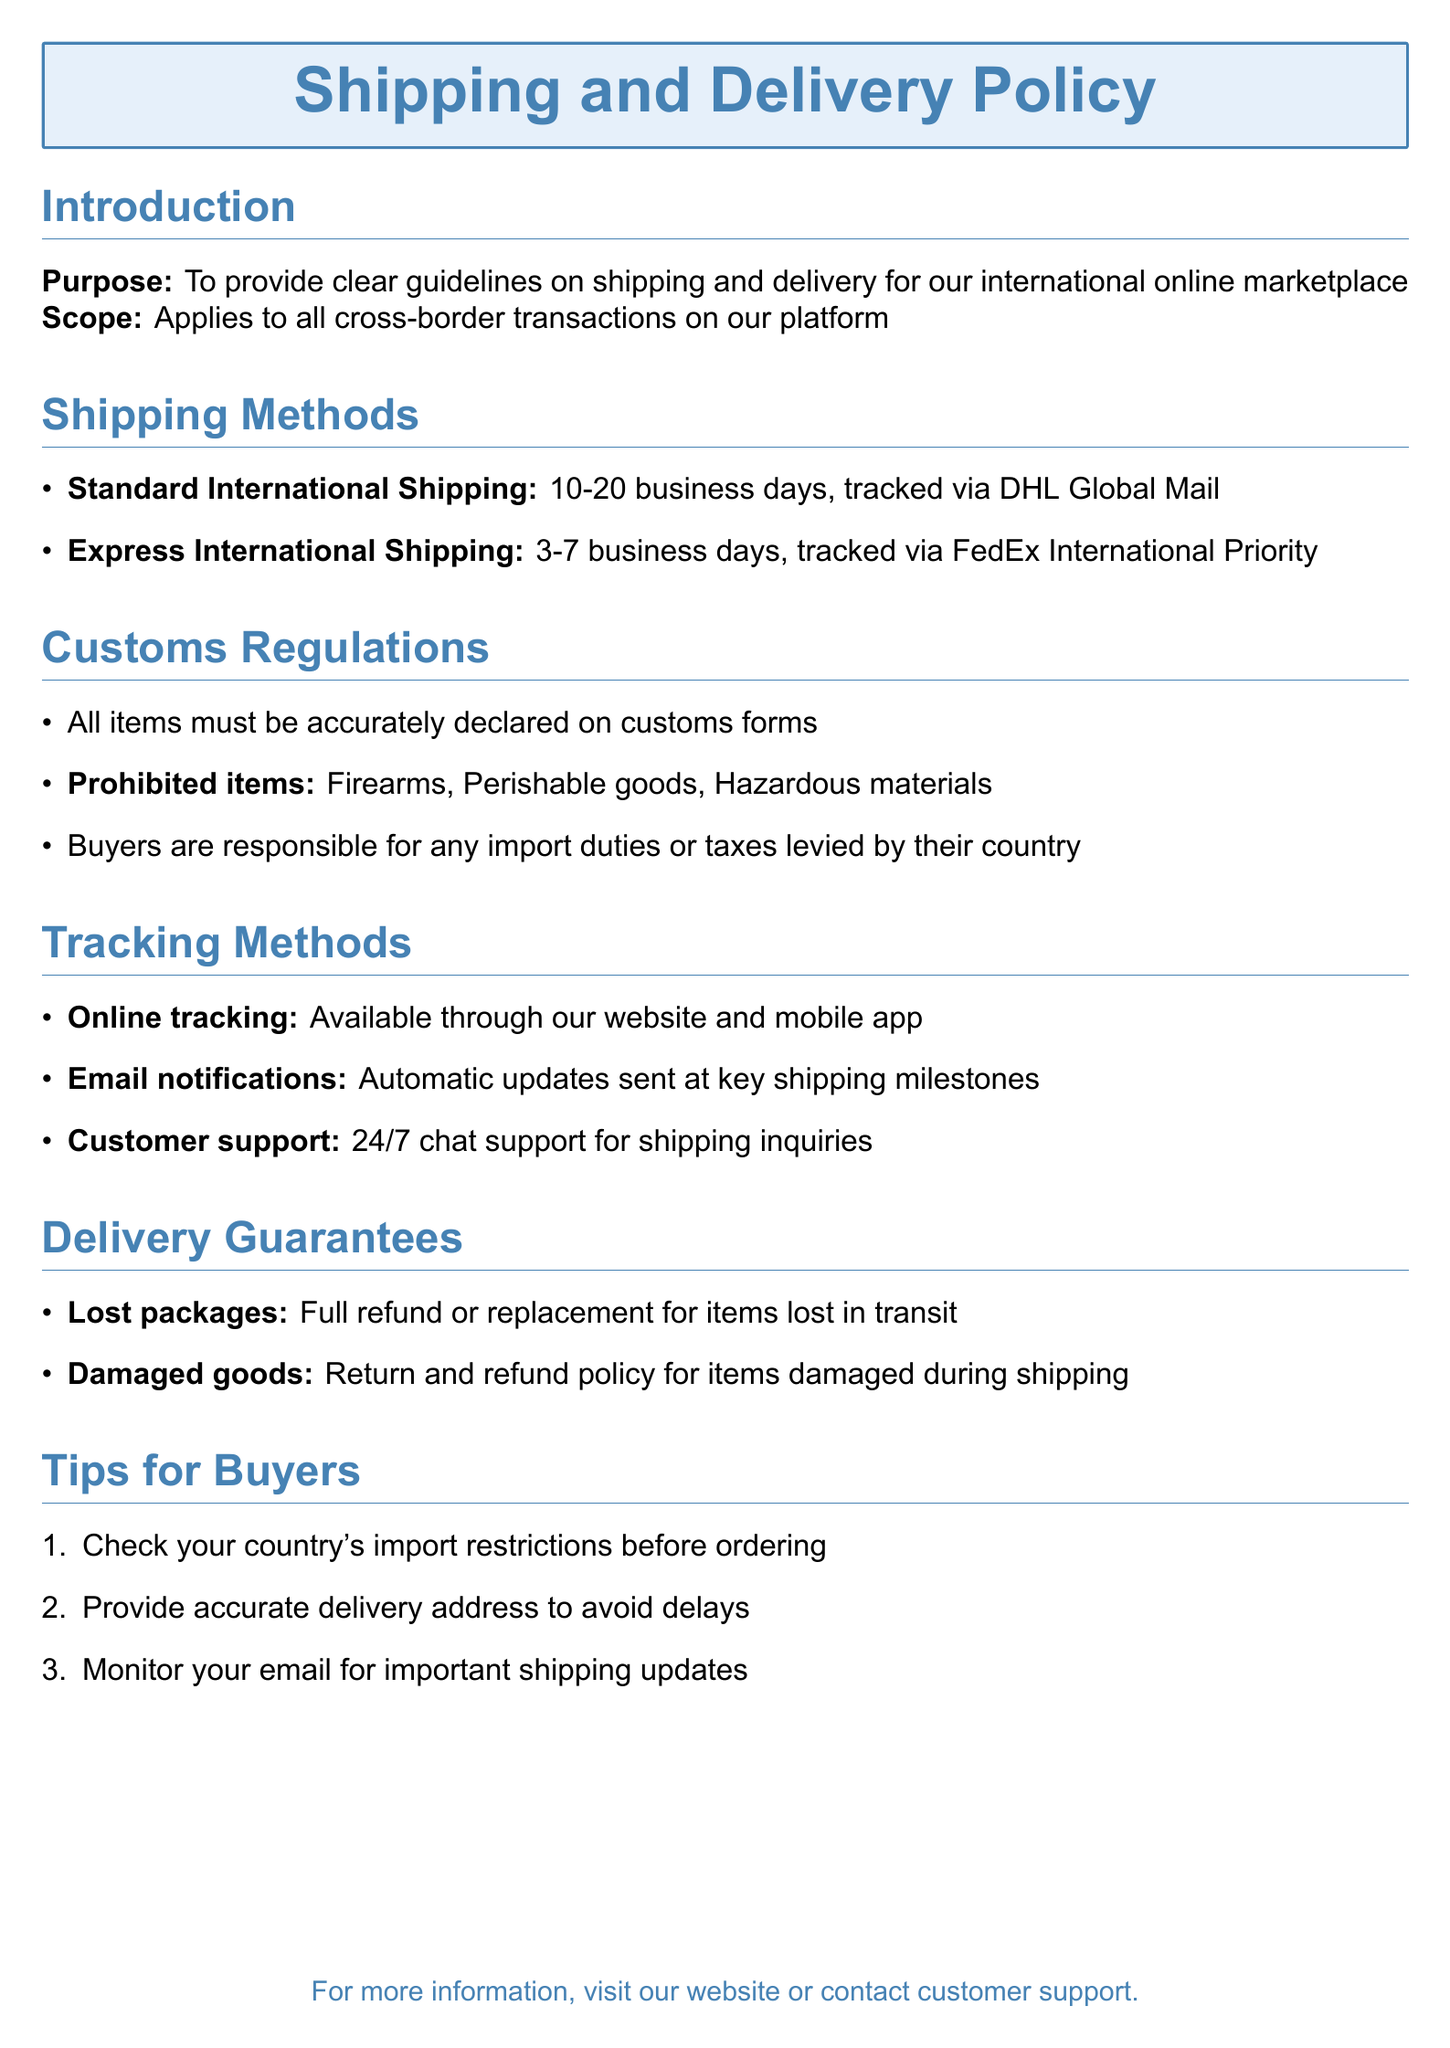What is the purpose of the document? The purpose is to provide clear guidelines on shipping and delivery for the international online marketplace.
Answer: To provide clear guidelines on shipping and delivery What is the expected delivery time for Express International Shipping? The delivery time for Express International Shipping is mentioned in the shipping methods section.
Answer: 3-7 business days What items are prohibited according to customs regulations? Prohibited items are listed in the customs regulations section of the document.
Answer: Firearms, Perishable goods, Hazardous materials What tracking method is available through our website? The tracking methods section outlines available tracking methods.
Answer: Online tracking What do buyers need to check before ordering? The tips for buyers section provides advice on what to check before ordering.
Answer: Check your country's import restrictions What should be done if a package is lost? The delivery guarantees section specifies the action for lost packages.
Answer: Full refund or replacement How can buyers receive updates on their shipment? Email notifications are mentioned in the tracking methods section as automatic updates.
Answer: Automatic updates sent at key shipping milestones What customer support option is available for shipping inquiries? The tracking methods section mentions support options available to customers.
Answer: 24/7 chat support 